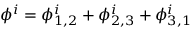<formula> <loc_0><loc_0><loc_500><loc_500>\phi ^ { i } = \phi _ { 1 , 2 } ^ { i } + \phi _ { 2 , 3 } ^ { i } + \phi _ { 3 , 1 } ^ { i }</formula> 